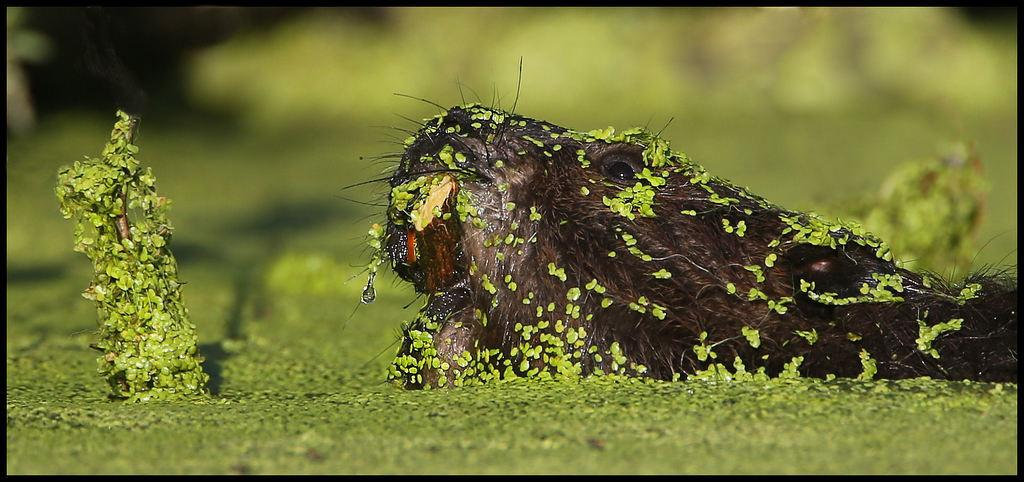What type of living creature is in the image? There is an animal in the image. What can be seen at the bottom of the image? There are leaves at the bottom of the image. How would you describe the background of the image? The background of the image is blurry. What is the weight of the monkey in the image? There is no monkey present in the image, so it is not possible to determine its weight. 